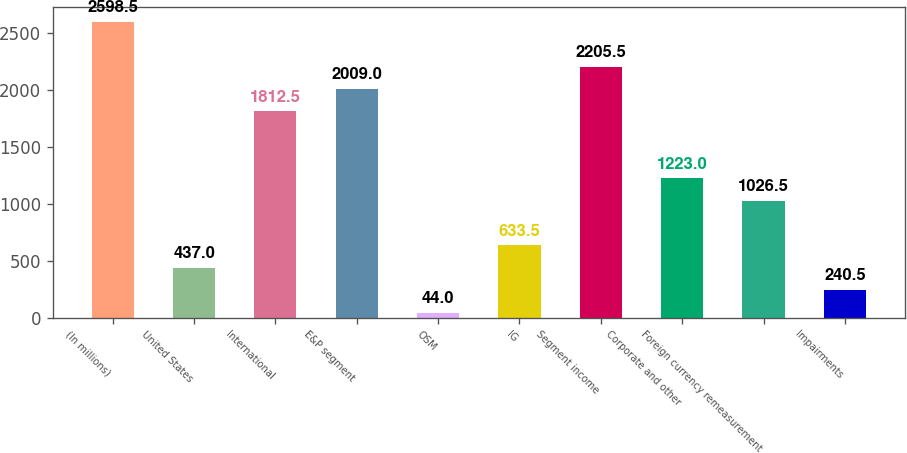Convert chart. <chart><loc_0><loc_0><loc_500><loc_500><bar_chart><fcel>(In millions)<fcel>United States<fcel>International<fcel>E&P segment<fcel>OSM<fcel>IG<fcel>Segment income<fcel>Corporate and other<fcel>Foreign currency remeasurement<fcel>Impairments<nl><fcel>2598.5<fcel>437<fcel>1812.5<fcel>2009<fcel>44<fcel>633.5<fcel>2205.5<fcel>1223<fcel>1026.5<fcel>240.5<nl></chart> 